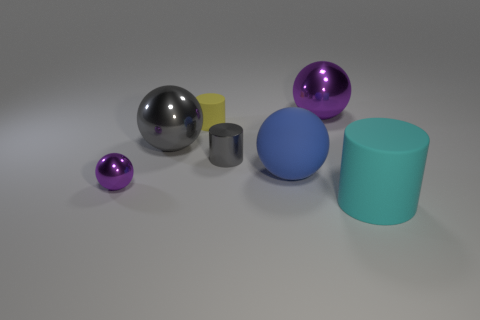The rubber thing behind the large matte object that is to the left of the cyan rubber object is what shape?
Your response must be concise. Cylinder. There is a metal object that is in front of the gray shiny sphere and to the right of the small rubber cylinder; what is its shape?
Offer a very short reply. Cylinder. How many objects are large rubber objects or cylinders in front of the small gray metal cylinder?
Your response must be concise. 2. There is a yellow object that is the same shape as the cyan object; what is its material?
Provide a succinct answer. Rubber. Is there any other thing that has the same material as the large gray ball?
Provide a succinct answer. Yes. There is a ball that is in front of the small rubber cylinder and on the right side of the tiny matte thing; what is its material?
Offer a terse response. Rubber. What number of gray shiny things have the same shape as the big cyan matte object?
Keep it short and to the point. 1. There is a large sphere in front of the gray thing in front of the gray shiny ball; what color is it?
Keep it short and to the point. Blue. Are there the same number of tiny rubber cylinders that are to the left of the blue ball and large purple matte cylinders?
Make the answer very short. No. Are there any yellow cylinders that have the same size as the blue thing?
Offer a terse response. No. 